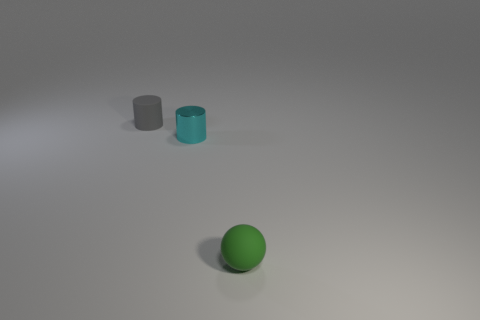Add 3 small cyan objects. How many objects exist? 6 Subtract all balls. How many objects are left? 2 Add 2 tiny green spheres. How many tiny green spheres exist? 3 Subtract 1 cyan cylinders. How many objects are left? 2 Subtract all small green rubber things. Subtract all gray matte cylinders. How many objects are left? 1 Add 2 green rubber spheres. How many green rubber spheres are left? 3 